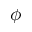Convert formula to latex. <formula><loc_0><loc_0><loc_500><loc_500>\phi</formula> 